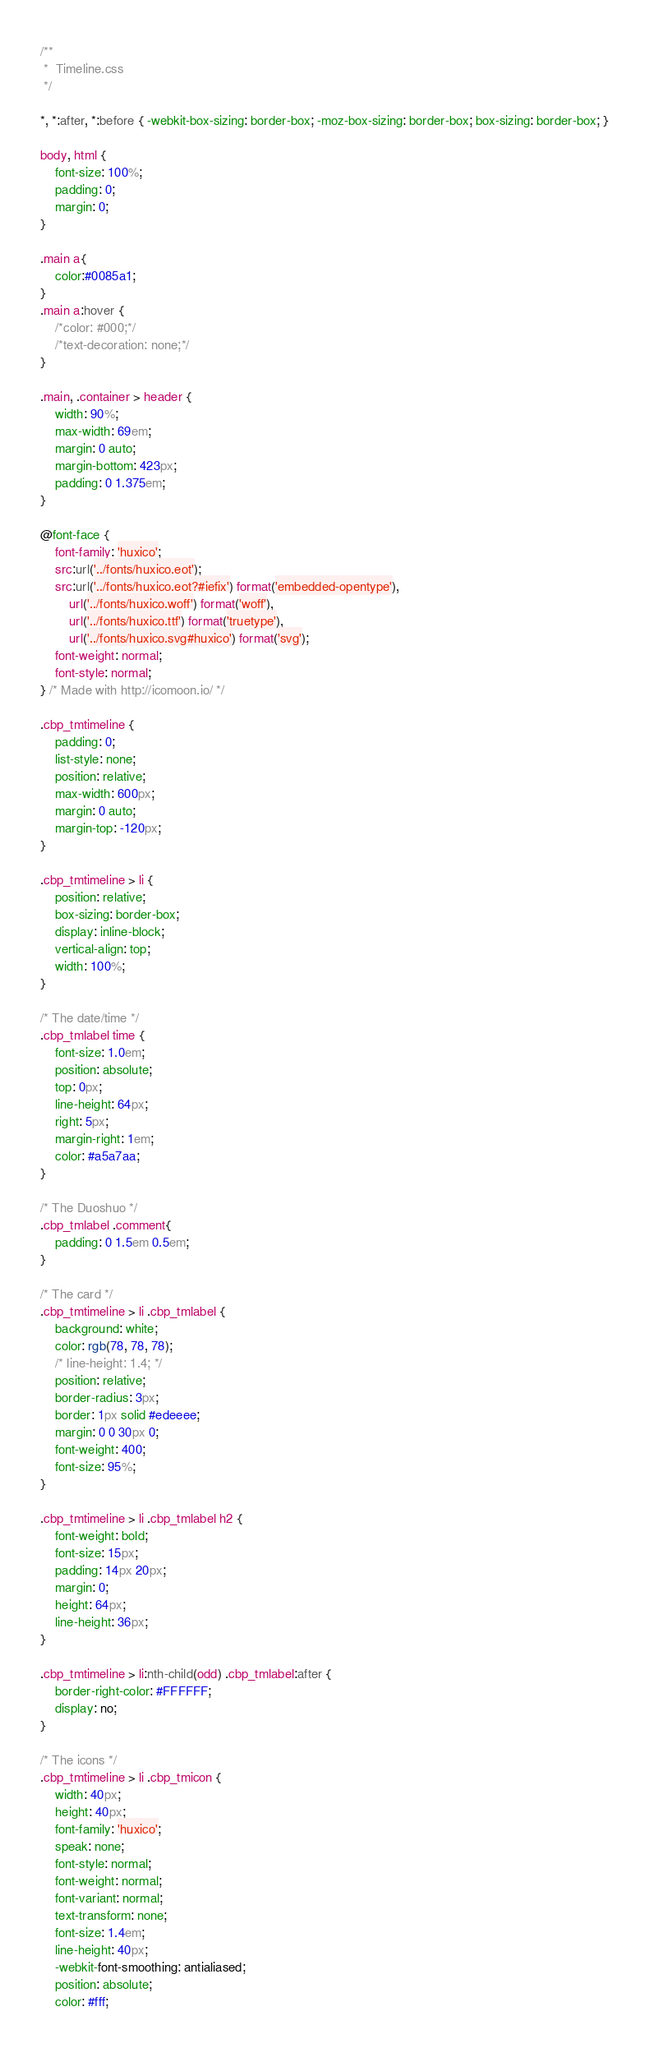<code> <loc_0><loc_0><loc_500><loc_500><_CSS_>/**
 *  Timeline.css
 */

*, *:after, *:before { -webkit-box-sizing: border-box; -moz-box-sizing: border-box; box-sizing: border-box; }

body, html {
	font-size: 100%;
	padding: 0;
	margin: 0;
}

.main a{
	color:#0085a1;
}
.main a:hover {
	/*color: #000;*/
	/*text-decoration: none;*/
}

.main, .container > header {
	width: 90%;
	max-width: 69em;
	margin: 0 auto;
	margin-bottom: 423px;
	padding: 0 1.375em;
}

@font-face {
	font-family: 'huxico';
	src:url('../fonts/huxico.eot');
	src:url('../fonts/huxico.eot?#iefix') format('embedded-opentype'),
		url('../fonts/huxico.woff') format('woff'),
		url('../fonts/huxico.ttf') format('truetype'),
		url('../fonts/huxico.svg#huxico') format('svg');
	font-weight: normal;
	font-style: normal;
} /* Made with http://icomoon.io/ */

.cbp_tmtimeline {
	padding: 0;
	list-style: none;
	position: relative;
	max-width: 600px;
	margin: 0 auto;
	margin-top: -120px;
}

.cbp_tmtimeline > li {
	position: relative;
	box-sizing: border-box;
	display: inline-block;
	vertical-align: top;
	width: 100%;
}

/* The date/time */
.cbp_tmlabel time {
	font-size: 1.0em;
	position: absolute;
	top: 0px;
	line-height: 64px;
	right: 5px;
	margin-right: 1em;
	color: #a5a7aa;
}

/* The Duoshuo */
.cbp_tmlabel .comment{
	padding: 0 1.5em 0.5em;
}

/* The card */
.cbp_tmtimeline > li .cbp_tmlabel {
	background: white;
	color: rgb(78, 78, 78);
	/* line-height: 1.4; */
	position: relative;
	border-radius: 3px;
	border: 1px solid #edeeee;
	margin: 0 0 30px 0;
	font-weight: 400;
	font-size: 95%;
}

.cbp_tmtimeline > li .cbp_tmlabel h2 {
	font-weight: bold;
	font-size: 15px;
	padding: 14px 20px;
	margin: 0;
	height: 64px;
	line-height: 36px;
}

.cbp_tmtimeline > li:nth-child(odd) .cbp_tmlabel:after {
	border-right-color: #FFFFFF;
	display: no;
}

/* The icons */
.cbp_tmtimeline > li .cbp_tmicon {
	width: 40px;
	height: 40px;
	font-family: 'huxico';
	speak: none;
	font-style: normal;
	font-weight: normal;
	font-variant: normal;
	text-transform: none;
	font-size: 1.4em;
	line-height: 40px;
	-webkit-font-smoothing: antialiased;
	position: absolute;
	color: #fff;</code> 